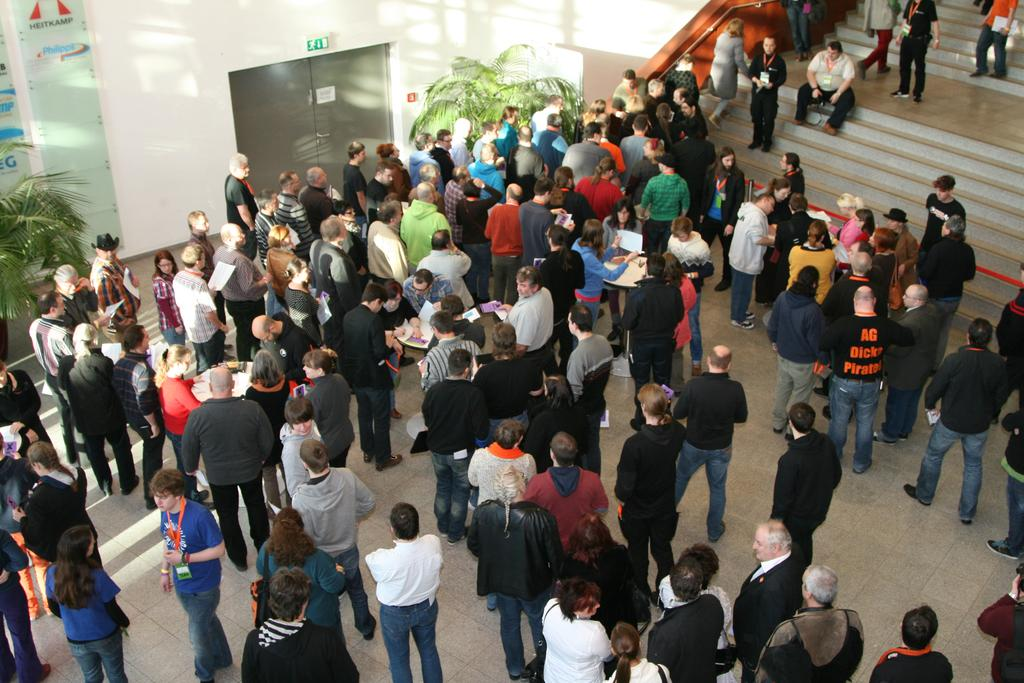What is the main focus of the image? The main focus of the image is the many people standing in the center. What architectural features can be seen in the image? There are staircases in the image. What type of vegetation is present in the image? There are plants in the image. What transportation option is visible in the background? There is a lift in the background of the image. What type of riddle is being solved by the people in the image? There is no riddle present in the image. Can you tell me what type of butter is being used in the image? There is no butter present in the image. 